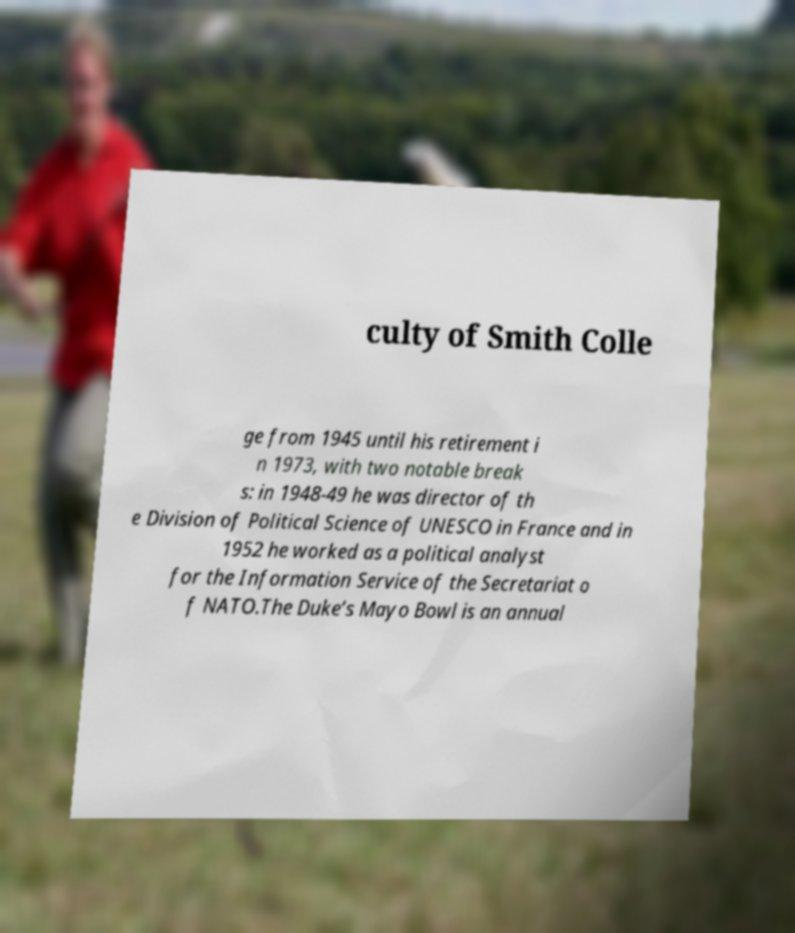What messages or text are displayed in this image? I need them in a readable, typed format. culty of Smith Colle ge from 1945 until his retirement i n 1973, with two notable break s: in 1948-49 he was director of th e Division of Political Science of UNESCO in France and in 1952 he worked as a political analyst for the Information Service of the Secretariat o f NATO.The Duke’s Mayo Bowl is an annual 